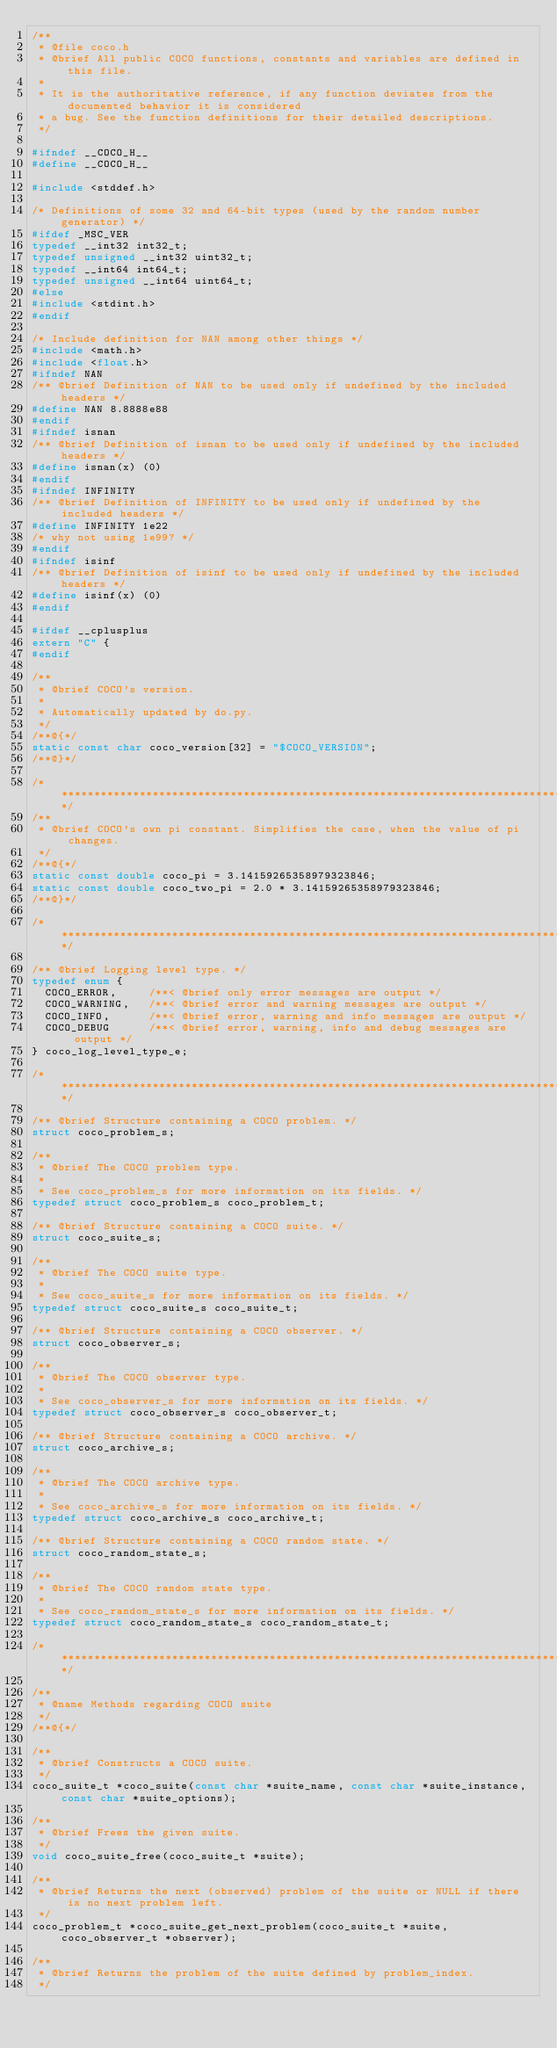<code> <loc_0><loc_0><loc_500><loc_500><_C_>/**
 * @file coco.h
 * @brief All public COCO functions, constants and variables are defined in this file.
 *
 * It is the authoritative reference, if any function deviates from the documented behavior it is considered
 * a bug. See the function definitions for their detailed descriptions.
 */
 
#ifndef __COCO_H__
#define __COCO_H__

#include <stddef.h>

/* Definitions of some 32 and 64-bit types (used by the random number generator) */
#ifdef _MSC_VER
typedef __int32 int32_t;
typedef unsigned __int32 uint32_t;
typedef __int64 int64_t;
typedef unsigned __int64 uint64_t;
#else
#include <stdint.h>
#endif

/* Include definition for NAN among other things */
#include <math.h>
#include <float.h>
#ifndef NAN
/** @brief Definition of NAN to be used only if undefined by the included headers */
#define NAN 8.8888e88
#endif
#ifndef isnan
/** @brief Definition of isnan to be used only if undefined by the included headers */
#define isnan(x) (0)
#endif
#ifndef INFINITY
/** @brief Definition of INFINITY to be used only if undefined by the included headers */
#define INFINITY 1e22
/* why not using 1e99? */
#endif
#ifndef isinf
/** @brief Definition of isinf to be used only if undefined by the included headers */
#define isinf(x) (0)
#endif

#ifdef __cplusplus
extern "C" {
#endif

/**
 * @brief COCO's version.
 *
 * Automatically updated by do.py.
 */
/**@{*/
static const char coco_version[32] = "$COCO_VERSION";
/**@}*/

/***********************************************************************************************************/
/**
 * @brief COCO's own pi constant. Simplifies the case, when the value of pi changes.
 */
/**@{*/
static const double coco_pi = 3.14159265358979323846;
static const double coco_two_pi = 2.0 * 3.14159265358979323846;
/**@}*/

/***********************************************************************************************************/

/** @brief Logging level type. */
typedef enum {
  COCO_ERROR,     /**< @brief only error messages are output */
  COCO_WARNING,   /**< @brief error and warning messages are output */
  COCO_INFO,      /**< @brief error, warning and info messages are output */
  COCO_DEBUG      /**< @brief error, warning, info and debug messages are output */
} coco_log_level_type_e;

/***********************************************************************************************************/

/** @brief Structure containing a COCO problem. */
struct coco_problem_s;

/**
 * @brief The COCO problem type.
 *
 * See coco_problem_s for more information on its fields. */
typedef struct coco_problem_s coco_problem_t;

/** @brief Structure containing a COCO suite. */
struct coco_suite_s;

/**
 * @brief The COCO suite type.
 *
 * See coco_suite_s for more information on its fields. */
typedef struct coco_suite_s coco_suite_t;

/** @brief Structure containing a COCO observer. */
struct coco_observer_s;

/**
 * @brief The COCO observer type.
 *
 * See coco_observer_s for more information on its fields. */
typedef struct coco_observer_s coco_observer_t;

/** @brief Structure containing a COCO archive. */
struct coco_archive_s;

/**
 * @brief The COCO archive type.
 *
 * See coco_archive_s for more information on its fields. */
typedef struct coco_archive_s coco_archive_t;

/** @brief Structure containing a COCO random state. */
struct coco_random_state_s;

/**
 * @brief The COCO random state type.
 *
 * See coco_random_state_s for more information on its fields. */
typedef struct coco_random_state_s coco_random_state_t;

/***********************************************************************************************************/

/**
 * @name Methods regarding COCO suite
 */
/**@{*/

/**
 * @brief Constructs a COCO suite.
 */
coco_suite_t *coco_suite(const char *suite_name, const char *suite_instance, const char *suite_options);

/**
 * @brief Frees the given suite.
 */
void coco_suite_free(coco_suite_t *suite);

/**
 * @brief Returns the next (observed) problem of the suite or NULL if there is no next problem left.
 */
coco_problem_t *coco_suite_get_next_problem(coco_suite_t *suite, coco_observer_t *observer);

/**
 * @brief Returns the problem of the suite defined by problem_index.
 */</code> 